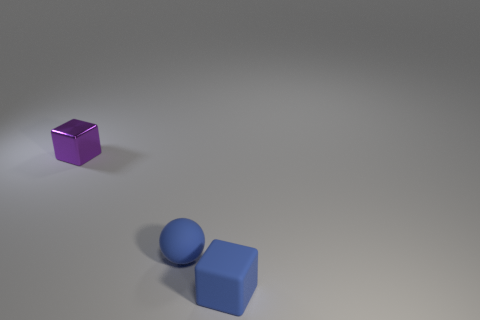Subtract all cubes. How many objects are left? 1 Subtract all blue cubes. How many cubes are left? 1 Add 1 tiny spheres. How many tiny spheres are left? 2 Add 3 small metallic objects. How many small metallic objects exist? 4 Add 3 small spheres. How many objects exist? 6 Subtract 0 brown blocks. How many objects are left? 3 Subtract 1 spheres. How many spheres are left? 0 Subtract all purple balls. Subtract all yellow cubes. How many balls are left? 1 Subtract all red spheres. How many blue blocks are left? 1 Subtract all small gray balls. Subtract all blue matte things. How many objects are left? 1 